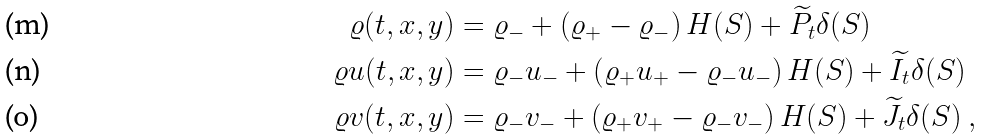Convert formula to latex. <formula><loc_0><loc_0><loc_500><loc_500>\varrho ( t , x , y ) & = \varrho _ { - } + \left ( \varrho _ { + } - \varrho _ { - } \right ) H ( S ) + \widetilde { P _ { t } } \delta ( S ) \\ \varrho u ( t , x , y ) & = \varrho _ { - } u _ { - } + \left ( \varrho _ { + } u _ { + } - \varrho _ { - } u _ { - } \right ) H ( S ) + \widetilde { I _ { t } } \delta ( S ) \\ \varrho v ( t , x , y ) & = \varrho _ { - } v _ { - } + \left ( \varrho _ { + } v _ { + } - \varrho _ { - } v _ { - } \right ) H ( S ) + \widetilde { J _ { t } } \delta ( S ) \ ,</formula> 